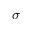<formula> <loc_0><loc_0><loc_500><loc_500>\boldsymbol \sigma</formula> 